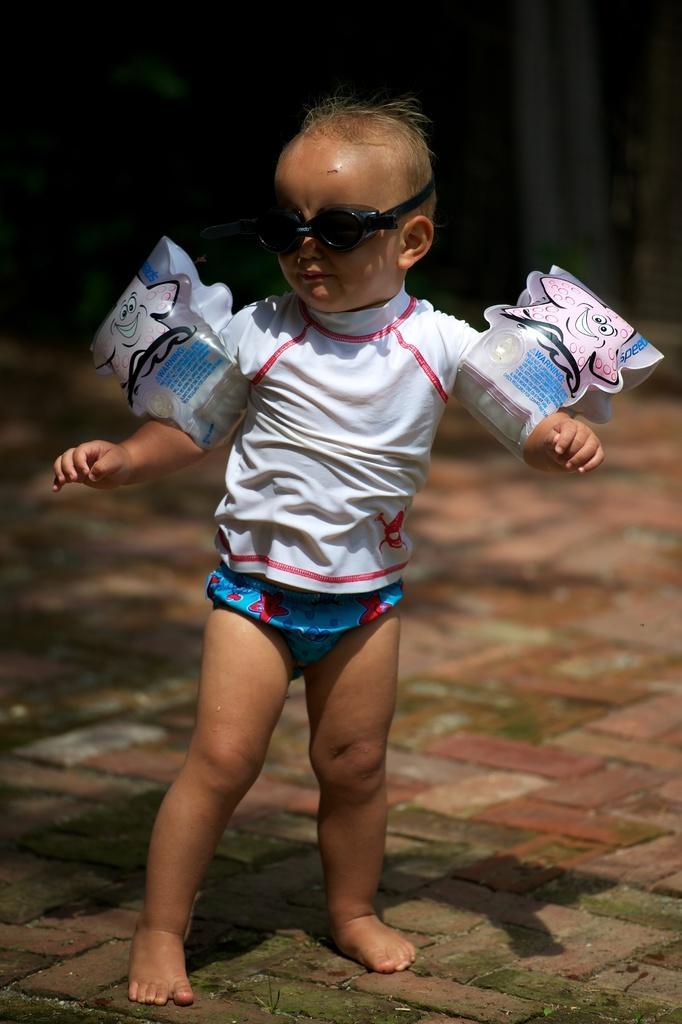Can you describe this image briefly? In this image there is a kid standing on the floor. He is wearing goggles. Background is blurry. 